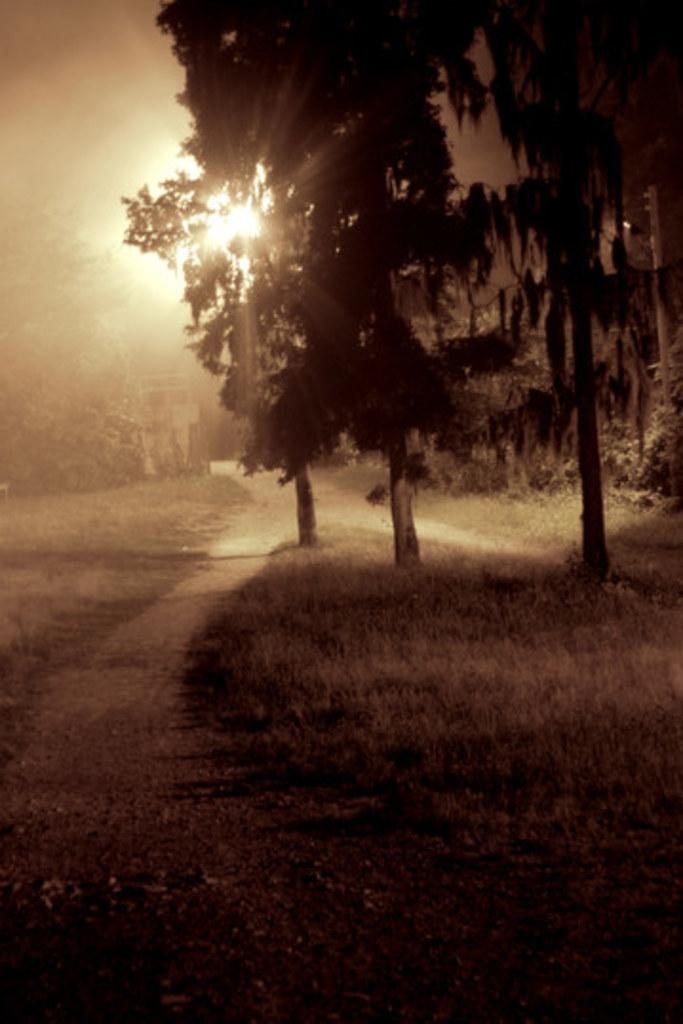What type of vegetation can be seen in the image? There are trees and grass in the image. What type of structure is present in the image? There is a house in the image. What celestial body is visible in the image? The sun is visible in the image. What else can be seen in the sky in the image? The sky is visible in the image. What type of caption is written on the grass in the image? There is no caption written on the grass in the image. Can you see any marbles rolling on the ground in the image? There are no marbles present in the image. 